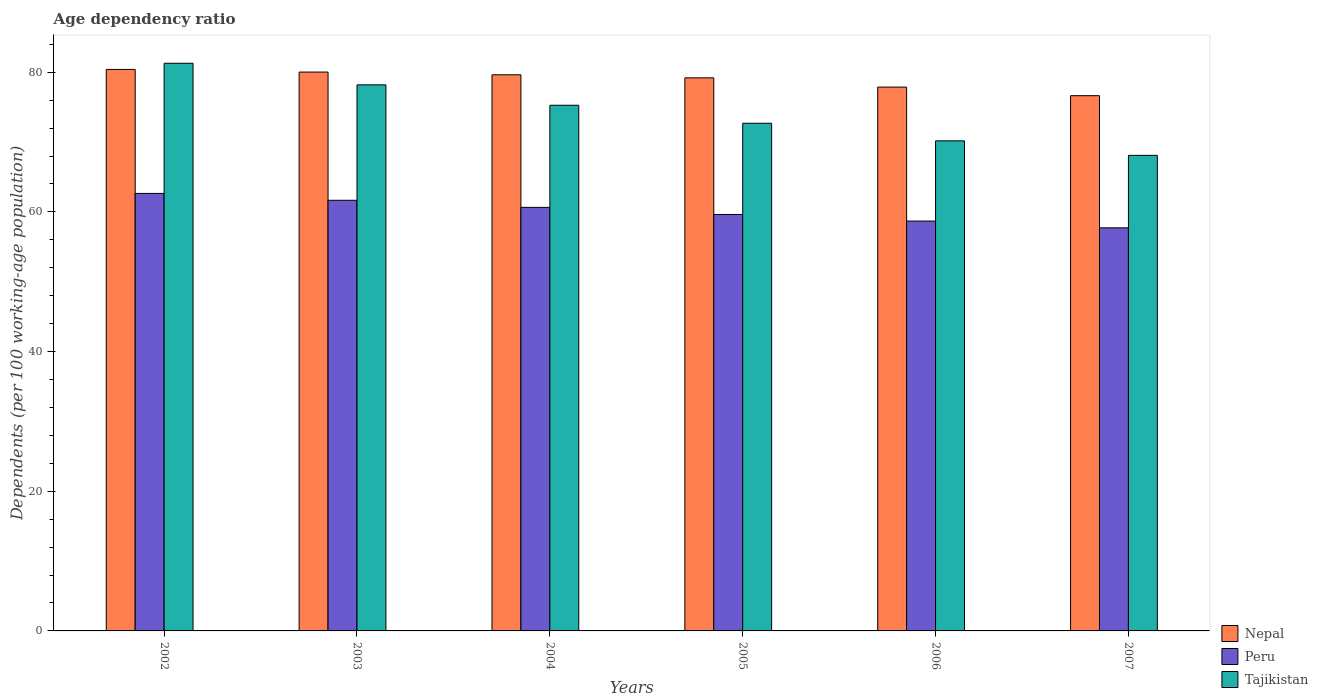How many different coloured bars are there?
Your response must be concise. 3. Are the number of bars per tick equal to the number of legend labels?
Keep it short and to the point. Yes. What is the label of the 6th group of bars from the left?
Offer a terse response. 2007. What is the age dependency ratio in in Tajikistan in 2003?
Keep it short and to the point. 78.2. Across all years, what is the maximum age dependency ratio in in Peru?
Offer a very short reply. 62.65. Across all years, what is the minimum age dependency ratio in in Nepal?
Offer a terse response. 76.65. In which year was the age dependency ratio in in Nepal minimum?
Give a very brief answer. 2007. What is the total age dependency ratio in in Tajikistan in the graph?
Give a very brief answer. 445.73. What is the difference between the age dependency ratio in in Peru in 2002 and that in 2003?
Offer a terse response. 0.98. What is the difference between the age dependency ratio in in Nepal in 2007 and the age dependency ratio in in Tajikistan in 2004?
Offer a terse response. 1.37. What is the average age dependency ratio in in Tajikistan per year?
Provide a succinct answer. 74.29. In the year 2003, what is the difference between the age dependency ratio in in Nepal and age dependency ratio in in Peru?
Keep it short and to the point. 18.36. What is the ratio of the age dependency ratio in in Peru in 2005 to that in 2006?
Make the answer very short. 1.02. Is the difference between the age dependency ratio in in Nepal in 2004 and 2007 greater than the difference between the age dependency ratio in in Peru in 2004 and 2007?
Make the answer very short. Yes. What is the difference between the highest and the second highest age dependency ratio in in Peru?
Make the answer very short. 0.98. What is the difference between the highest and the lowest age dependency ratio in in Tajikistan?
Offer a very short reply. 13.19. What does the 1st bar from the left in 2006 represents?
Ensure brevity in your answer.  Nepal. How many bars are there?
Ensure brevity in your answer.  18. How many years are there in the graph?
Your answer should be very brief. 6. What is the difference between two consecutive major ticks on the Y-axis?
Your response must be concise. 20. Are the values on the major ticks of Y-axis written in scientific E-notation?
Your answer should be very brief. No. Where does the legend appear in the graph?
Give a very brief answer. Bottom right. How many legend labels are there?
Your response must be concise. 3. What is the title of the graph?
Provide a short and direct response. Age dependency ratio. Does "Libya" appear as one of the legend labels in the graph?
Keep it short and to the point. No. What is the label or title of the Y-axis?
Make the answer very short. Dependents (per 100 working-age population). What is the Dependents (per 100 working-age population) of Nepal in 2002?
Your answer should be compact. 80.41. What is the Dependents (per 100 working-age population) of Peru in 2002?
Your answer should be very brief. 62.65. What is the Dependents (per 100 working-age population) in Tajikistan in 2002?
Make the answer very short. 81.29. What is the Dependents (per 100 working-age population) of Nepal in 2003?
Ensure brevity in your answer.  80.03. What is the Dependents (per 100 working-age population) of Peru in 2003?
Provide a succinct answer. 61.67. What is the Dependents (per 100 working-age population) of Tajikistan in 2003?
Give a very brief answer. 78.2. What is the Dependents (per 100 working-age population) in Nepal in 2004?
Keep it short and to the point. 79.64. What is the Dependents (per 100 working-age population) of Peru in 2004?
Keep it short and to the point. 60.65. What is the Dependents (per 100 working-age population) of Tajikistan in 2004?
Make the answer very short. 75.27. What is the Dependents (per 100 working-age population) of Nepal in 2005?
Ensure brevity in your answer.  79.2. What is the Dependents (per 100 working-age population) of Peru in 2005?
Make the answer very short. 59.63. What is the Dependents (per 100 working-age population) of Tajikistan in 2005?
Keep it short and to the point. 72.7. What is the Dependents (per 100 working-age population) in Nepal in 2006?
Your answer should be compact. 77.88. What is the Dependents (per 100 working-age population) in Peru in 2006?
Offer a very short reply. 58.69. What is the Dependents (per 100 working-age population) in Tajikistan in 2006?
Make the answer very short. 70.18. What is the Dependents (per 100 working-age population) in Nepal in 2007?
Keep it short and to the point. 76.65. What is the Dependents (per 100 working-age population) in Peru in 2007?
Your response must be concise. 57.72. What is the Dependents (per 100 working-age population) in Tajikistan in 2007?
Offer a very short reply. 68.1. Across all years, what is the maximum Dependents (per 100 working-age population) of Nepal?
Your answer should be compact. 80.41. Across all years, what is the maximum Dependents (per 100 working-age population) in Peru?
Offer a terse response. 62.65. Across all years, what is the maximum Dependents (per 100 working-age population) of Tajikistan?
Make the answer very short. 81.29. Across all years, what is the minimum Dependents (per 100 working-age population) of Nepal?
Your response must be concise. 76.65. Across all years, what is the minimum Dependents (per 100 working-age population) of Peru?
Provide a succinct answer. 57.72. Across all years, what is the minimum Dependents (per 100 working-age population) of Tajikistan?
Your answer should be very brief. 68.1. What is the total Dependents (per 100 working-age population) of Nepal in the graph?
Provide a succinct answer. 473.79. What is the total Dependents (per 100 working-age population) of Peru in the graph?
Your answer should be very brief. 361.02. What is the total Dependents (per 100 working-age population) in Tajikistan in the graph?
Your answer should be compact. 445.73. What is the difference between the Dependents (per 100 working-age population) of Nepal in 2002 and that in 2003?
Offer a very short reply. 0.38. What is the difference between the Dependents (per 100 working-age population) of Peru in 2002 and that in 2003?
Ensure brevity in your answer.  0.98. What is the difference between the Dependents (per 100 working-age population) in Tajikistan in 2002 and that in 2003?
Make the answer very short. 3.09. What is the difference between the Dependents (per 100 working-age population) of Nepal in 2002 and that in 2004?
Ensure brevity in your answer.  0.77. What is the difference between the Dependents (per 100 working-age population) of Peru in 2002 and that in 2004?
Your answer should be compact. 2. What is the difference between the Dependents (per 100 working-age population) of Tajikistan in 2002 and that in 2004?
Make the answer very short. 6.01. What is the difference between the Dependents (per 100 working-age population) of Nepal in 2002 and that in 2005?
Provide a short and direct response. 1.21. What is the difference between the Dependents (per 100 working-age population) of Peru in 2002 and that in 2005?
Your answer should be compact. 3.02. What is the difference between the Dependents (per 100 working-age population) in Tajikistan in 2002 and that in 2005?
Keep it short and to the point. 8.59. What is the difference between the Dependents (per 100 working-age population) of Nepal in 2002 and that in 2006?
Keep it short and to the point. 2.53. What is the difference between the Dependents (per 100 working-age population) of Peru in 2002 and that in 2006?
Provide a short and direct response. 3.96. What is the difference between the Dependents (per 100 working-age population) of Tajikistan in 2002 and that in 2006?
Offer a terse response. 11.11. What is the difference between the Dependents (per 100 working-age population) of Nepal in 2002 and that in 2007?
Provide a short and direct response. 3.76. What is the difference between the Dependents (per 100 working-age population) in Peru in 2002 and that in 2007?
Provide a short and direct response. 4.93. What is the difference between the Dependents (per 100 working-age population) of Tajikistan in 2002 and that in 2007?
Keep it short and to the point. 13.19. What is the difference between the Dependents (per 100 working-age population) of Nepal in 2003 and that in 2004?
Provide a succinct answer. 0.39. What is the difference between the Dependents (per 100 working-age population) in Peru in 2003 and that in 2004?
Keep it short and to the point. 1.01. What is the difference between the Dependents (per 100 working-age population) in Tajikistan in 2003 and that in 2004?
Offer a very short reply. 2.92. What is the difference between the Dependents (per 100 working-age population) of Nepal in 2003 and that in 2005?
Your answer should be compact. 0.83. What is the difference between the Dependents (per 100 working-age population) of Peru in 2003 and that in 2005?
Offer a very short reply. 2.03. What is the difference between the Dependents (per 100 working-age population) in Tajikistan in 2003 and that in 2005?
Provide a short and direct response. 5.5. What is the difference between the Dependents (per 100 working-age population) in Nepal in 2003 and that in 2006?
Provide a succinct answer. 2.15. What is the difference between the Dependents (per 100 working-age population) in Peru in 2003 and that in 2006?
Provide a succinct answer. 2.97. What is the difference between the Dependents (per 100 working-age population) in Tajikistan in 2003 and that in 2006?
Your response must be concise. 8.02. What is the difference between the Dependents (per 100 working-age population) of Nepal in 2003 and that in 2007?
Your response must be concise. 3.38. What is the difference between the Dependents (per 100 working-age population) in Peru in 2003 and that in 2007?
Your answer should be very brief. 3.94. What is the difference between the Dependents (per 100 working-age population) in Tajikistan in 2003 and that in 2007?
Offer a very short reply. 10.09. What is the difference between the Dependents (per 100 working-age population) in Nepal in 2004 and that in 2005?
Your response must be concise. 0.44. What is the difference between the Dependents (per 100 working-age population) in Peru in 2004 and that in 2005?
Ensure brevity in your answer.  1.02. What is the difference between the Dependents (per 100 working-age population) in Tajikistan in 2004 and that in 2005?
Your answer should be very brief. 2.58. What is the difference between the Dependents (per 100 working-age population) of Nepal in 2004 and that in 2006?
Your answer should be very brief. 1.76. What is the difference between the Dependents (per 100 working-age population) of Peru in 2004 and that in 2006?
Your response must be concise. 1.96. What is the difference between the Dependents (per 100 working-age population) in Tajikistan in 2004 and that in 2006?
Your response must be concise. 5.1. What is the difference between the Dependents (per 100 working-age population) of Nepal in 2004 and that in 2007?
Provide a succinct answer. 2.99. What is the difference between the Dependents (per 100 working-age population) in Peru in 2004 and that in 2007?
Provide a succinct answer. 2.93. What is the difference between the Dependents (per 100 working-age population) of Tajikistan in 2004 and that in 2007?
Give a very brief answer. 7.17. What is the difference between the Dependents (per 100 working-age population) of Nepal in 2005 and that in 2006?
Your answer should be very brief. 1.32. What is the difference between the Dependents (per 100 working-age population) of Peru in 2005 and that in 2006?
Keep it short and to the point. 0.94. What is the difference between the Dependents (per 100 working-age population) in Tajikistan in 2005 and that in 2006?
Your response must be concise. 2.52. What is the difference between the Dependents (per 100 working-age population) of Nepal in 2005 and that in 2007?
Your answer should be very brief. 2.55. What is the difference between the Dependents (per 100 working-age population) of Peru in 2005 and that in 2007?
Provide a short and direct response. 1.91. What is the difference between the Dependents (per 100 working-age population) in Tajikistan in 2005 and that in 2007?
Provide a short and direct response. 4.59. What is the difference between the Dependents (per 100 working-age population) of Nepal in 2006 and that in 2007?
Provide a succinct answer. 1.23. What is the difference between the Dependents (per 100 working-age population) in Peru in 2006 and that in 2007?
Your answer should be compact. 0.97. What is the difference between the Dependents (per 100 working-age population) in Tajikistan in 2006 and that in 2007?
Keep it short and to the point. 2.08. What is the difference between the Dependents (per 100 working-age population) of Nepal in 2002 and the Dependents (per 100 working-age population) of Peru in 2003?
Provide a succinct answer. 18.74. What is the difference between the Dependents (per 100 working-age population) of Nepal in 2002 and the Dependents (per 100 working-age population) of Tajikistan in 2003?
Your answer should be compact. 2.21. What is the difference between the Dependents (per 100 working-age population) of Peru in 2002 and the Dependents (per 100 working-age population) of Tajikistan in 2003?
Offer a terse response. -15.54. What is the difference between the Dependents (per 100 working-age population) in Nepal in 2002 and the Dependents (per 100 working-age population) in Peru in 2004?
Your answer should be very brief. 19.75. What is the difference between the Dependents (per 100 working-age population) in Nepal in 2002 and the Dependents (per 100 working-age population) in Tajikistan in 2004?
Provide a succinct answer. 5.13. What is the difference between the Dependents (per 100 working-age population) of Peru in 2002 and the Dependents (per 100 working-age population) of Tajikistan in 2004?
Offer a terse response. -12.62. What is the difference between the Dependents (per 100 working-age population) of Nepal in 2002 and the Dependents (per 100 working-age population) of Peru in 2005?
Provide a succinct answer. 20.77. What is the difference between the Dependents (per 100 working-age population) in Nepal in 2002 and the Dependents (per 100 working-age population) in Tajikistan in 2005?
Give a very brief answer. 7.71. What is the difference between the Dependents (per 100 working-age population) of Peru in 2002 and the Dependents (per 100 working-age population) of Tajikistan in 2005?
Make the answer very short. -10.05. What is the difference between the Dependents (per 100 working-age population) of Nepal in 2002 and the Dependents (per 100 working-age population) of Peru in 2006?
Keep it short and to the point. 21.71. What is the difference between the Dependents (per 100 working-age population) of Nepal in 2002 and the Dependents (per 100 working-age population) of Tajikistan in 2006?
Provide a short and direct response. 10.23. What is the difference between the Dependents (per 100 working-age population) in Peru in 2002 and the Dependents (per 100 working-age population) in Tajikistan in 2006?
Ensure brevity in your answer.  -7.53. What is the difference between the Dependents (per 100 working-age population) of Nepal in 2002 and the Dependents (per 100 working-age population) of Peru in 2007?
Offer a terse response. 22.68. What is the difference between the Dependents (per 100 working-age population) in Nepal in 2002 and the Dependents (per 100 working-age population) in Tajikistan in 2007?
Offer a very short reply. 12.3. What is the difference between the Dependents (per 100 working-age population) of Peru in 2002 and the Dependents (per 100 working-age population) of Tajikistan in 2007?
Give a very brief answer. -5.45. What is the difference between the Dependents (per 100 working-age population) of Nepal in 2003 and the Dependents (per 100 working-age population) of Peru in 2004?
Provide a short and direct response. 19.38. What is the difference between the Dependents (per 100 working-age population) of Nepal in 2003 and the Dependents (per 100 working-age population) of Tajikistan in 2004?
Offer a very short reply. 4.75. What is the difference between the Dependents (per 100 working-age population) in Peru in 2003 and the Dependents (per 100 working-age population) in Tajikistan in 2004?
Give a very brief answer. -13.61. What is the difference between the Dependents (per 100 working-age population) of Nepal in 2003 and the Dependents (per 100 working-age population) of Peru in 2005?
Offer a terse response. 20.39. What is the difference between the Dependents (per 100 working-age population) of Nepal in 2003 and the Dependents (per 100 working-age population) of Tajikistan in 2005?
Provide a short and direct response. 7.33. What is the difference between the Dependents (per 100 working-age population) of Peru in 2003 and the Dependents (per 100 working-age population) of Tajikistan in 2005?
Ensure brevity in your answer.  -11.03. What is the difference between the Dependents (per 100 working-age population) in Nepal in 2003 and the Dependents (per 100 working-age population) in Peru in 2006?
Provide a short and direct response. 21.33. What is the difference between the Dependents (per 100 working-age population) of Nepal in 2003 and the Dependents (per 100 working-age population) of Tajikistan in 2006?
Your response must be concise. 9.85. What is the difference between the Dependents (per 100 working-age population) of Peru in 2003 and the Dependents (per 100 working-age population) of Tajikistan in 2006?
Your answer should be compact. -8.51. What is the difference between the Dependents (per 100 working-age population) in Nepal in 2003 and the Dependents (per 100 working-age population) in Peru in 2007?
Keep it short and to the point. 22.3. What is the difference between the Dependents (per 100 working-age population) of Nepal in 2003 and the Dependents (per 100 working-age population) of Tajikistan in 2007?
Offer a very short reply. 11.92. What is the difference between the Dependents (per 100 working-age population) in Peru in 2003 and the Dependents (per 100 working-age population) in Tajikistan in 2007?
Your response must be concise. -6.44. What is the difference between the Dependents (per 100 working-age population) in Nepal in 2004 and the Dependents (per 100 working-age population) in Peru in 2005?
Your answer should be compact. 20. What is the difference between the Dependents (per 100 working-age population) in Nepal in 2004 and the Dependents (per 100 working-age population) in Tajikistan in 2005?
Offer a terse response. 6.94. What is the difference between the Dependents (per 100 working-age population) in Peru in 2004 and the Dependents (per 100 working-age population) in Tajikistan in 2005?
Make the answer very short. -12.05. What is the difference between the Dependents (per 100 working-age population) in Nepal in 2004 and the Dependents (per 100 working-age population) in Peru in 2006?
Offer a very short reply. 20.94. What is the difference between the Dependents (per 100 working-age population) in Nepal in 2004 and the Dependents (per 100 working-age population) in Tajikistan in 2006?
Offer a very short reply. 9.46. What is the difference between the Dependents (per 100 working-age population) in Peru in 2004 and the Dependents (per 100 working-age population) in Tajikistan in 2006?
Your answer should be compact. -9.53. What is the difference between the Dependents (per 100 working-age population) of Nepal in 2004 and the Dependents (per 100 working-age population) of Peru in 2007?
Offer a terse response. 21.91. What is the difference between the Dependents (per 100 working-age population) in Nepal in 2004 and the Dependents (per 100 working-age population) in Tajikistan in 2007?
Provide a short and direct response. 11.53. What is the difference between the Dependents (per 100 working-age population) of Peru in 2004 and the Dependents (per 100 working-age population) of Tajikistan in 2007?
Your answer should be very brief. -7.45. What is the difference between the Dependents (per 100 working-age population) of Nepal in 2005 and the Dependents (per 100 working-age population) of Peru in 2006?
Offer a very short reply. 20.51. What is the difference between the Dependents (per 100 working-age population) in Nepal in 2005 and the Dependents (per 100 working-age population) in Tajikistan in 2006?
Your response must be concise. 9.02. What is the difference between the Dependents (per 100 working-age population) of Peru in 2005 and the Dependents (per 100 working-age population) of Tajikistan in 2006?
Give a very brief answer. -10.54. What is the difference between the Dependents (per 100 working-age population) of Nepal in 2005 and the Dependents (per 100 working-age population) of Peru in 2007?
Give a very brief answer. 21.48. What is the difference between the Dependents (per 100 working-age population) of Nepal in 2005 and the Dependents (per 100 working-age population) of Tajikistan in 2007?
Your response must be concise. 11.1. What is the difference between the Dependents (per 100 working-age population) of Peru in 2005 and the Dependents (per 100 working-age population) of Tajikistan in 2007?
Give a very brief answer. -8.47. What is the difference between the Dependents (per 100 working-age population) in Nepal in 2006 and the Dependents (per 100 working-age population) in Peru in 2007?
Provide a short and direct response. 20.15. What is the difference between the Dependents (per 100 working-age population) of Nepal in 2006 and the Dependents (per 100 working-age population) of Tajikistan in 2007?
Keep it short and to the point. 9.77. What is the difference between the Dependents (per 100 working-age population) in Peru in 2006 and the Dependents (per 100 working-age population) in Tajikistan in 2007?
Make the answer very short. -9.41. What is the average Dependents (per 100 working-age population) in Nepal per year?
Make the answer very short. 78.96. What is the average Dependents (per 100 working-age population) of Peru per year?
Offer a terse response. 60.17. What is the average Dependents (per 100 working-age population) of Tajikistan per year?
Provide a short and direct response. 74.29. In the year 2002, what is the difference between the Dependents (per 100 working-age population) in Nepal and Dependents (per 100 working-age population) in Peru?
Offer a terse response. 17.75. In the year 2002, what is the difference between the Dependents (per 100 working-age population) in Nepal and Dependents (per 100 working-age population) in Tajikistan?
Offer a very short reply. -0.88. In the year 2002, what is the difference between the Dependents (per 100 working-age population) in Peru and Dependents (per 100 working-age population) in Tajikistan?
Offer a very short reply. -18.64. In the year 2003, what is the difference between the Dependents (per 100 working-age population) in Nepal and Dependents (per 100 working-age population) in Peru?
Offer a terse response. 18.36. In the year 2003, what is the difference between the Dependents (per 100 working-age population) of Nepal and Dependents (per 100 working-age population) of Tajikistan?
Provide a succinct answer. 1.83. In the year 2003, what is the difference between the Dependents (per 100 working-age population) in Peru and Dependents (per 100 working-age population) in Tajikistan?
Offer a very short reply. -16.53. In the year 2004, what is the difference between the Dependents (per 100 working-age population) of Nepal and Dependents (per 100 working-age population) of Peru?
Ensure brevity in your answer.  18.99. In the year 2004, what is the difference between the Dependents (per 100 working-age population) in Nepal and Dependents (per 100 working-age population) in Tajikistan?
Keep it short and to the point. 4.36. In the year 2004, what is the difference between the Dependents (per 100 working-age population) of Peru and Dependents (per 100 working-age population) of Tajikistan?
Keep it short and to the point. -14.62. In the year 2005, what is the difference between the Dependents (per 100 working-age population) in Nepal and Dependents (per 100 working-age population) in Peru?
Provide a succinct answer. 19.56. In the year 2005, what is the difference between the Dependents (per 100 working-age population) in Nepal and Dependents (per 100 working-age population) in Tajikistan?
Your answer should be compact. 6.5. In the year 2005, what is the difference between the Dependents (per 100 working-age population) in Peru and Dependents (per 100 working-age population) in Tajikistan?
Ensure brevity in your answer.  -13.06. In the year 2006, what is the difference between the Dependents (per 100 working-age population) of Nepal and Dependents (per 100 working-age population) of Peru?
Keep it short and to the point. 19.18. In the year 2006, what is the difference between the Dependents (per 100 working-age population) of Nepal and Dependents (per 100 working-age population) of Tajikistan?
Offer a very short reply. 7.7. In the year 2006, what is the difference between the Dependents (per 100 working-age population) of Peru and Dependents (per 100 working-age population) of Tajikistan?
Your answer should be compact. -11.49. In the year 2007, what is the difference between the Dependents (per 100 working-age population) in Nepal and Dependents (per 100 working-age population) in Peru?
Ensure brevity in your answer.  18.92. In the year 2007, what is the difference between the Dependents (per 100 working-age population) of Nepal and Dependents (per 100 working-age population) of Tajikistan?
Provide a succinct answer. 8.54. In the year 2007, what is the difference between the Dependents (per 100 working-age population) of Peru and Dependents (per 100 working-age population) of Tajikistan?
Provide a succinct answer. -10.38. What is the ratio of the Dependents (per 100 working-age population) of Peru in 2002 to that in 2003?
Give a very brief answer. 1.02. What is the ratio of the Dependents (per 100 working-age population) of Tajikistan in 2002 to that in 2003?
Offer a very short reply. 1.04. What is the ratio of the Dependents (per 100 working-age population) in Nepal in 2002 to that in 2004?
Your answer should be very brief. 1.01. What is the ratio of the Dependents (per 100 working-age population) in Peru in 2002 to that in 2004?
Your answer should be very brief. 1.03. What is the ratio of the Dependents (per 100 working-age population) in Tajikistan in 2002 to that in 2004?
Make the answer very short. 1.08. What is the ratio of the Dependents (per 100 working-age population) in Nepal in 2002 to that in 2005?
Give a very brief answer. 1.02. What is the ratio of the Dependents (per 100 working-age population) in Peru in 2002 to that in 2005?
Your answer should be compact. 1.05. What is the ratio of the Dependents (per 100 working-age population) of Tajikistan in 2002 to that in 2005?
Your answer should be very brief. 1.12. What is the ratio of the Dependents (per 100 working-age population) of Nepal in 2002 to that in 2006?
Your response must be concise. 1.03. What is the ratio of the Dependents (per 100 working-age population) in Peru in 2002 to that in 2006?
Give a very brief answer. 1.07. What is the ratio of the Dependents (per 100 working-age population) in Tajikistan in 2002 to that in 2006?
Provide a succinct answer. 1.16. What is the ratio of the Dependents (per 100 working-age population) in Nepal in 2002 to that in 2007?
Offer a terse response. 1.05. What is the ratio of the Dependents (per 100 working-age population) in Peru in 2002 to that in 2007?
Offer a very short reply. 1.09. What is the ratio of the Dependents (per 100 working-age population) of Tajikistan in 2002 to that in 2007?
Your response must be concise. 1.19. What is the ratio of the Dependents (per 100 working-age population) of Peru in 2003 to that in 2004?
Provide a succinct answer. 1.02. What is the ratio of the Dependents (per 100 working-age population) of Tajikistan in 2003 to that in 2004?
Ensure brevity in your answer.  1.04. What is the ratio of the Dependents (per 100 working-age population) in Nepal in 2003 to that in 2005?
Offer a very short reply. 1.01. What is the ratio of the Dependents (per 100 working-age population) in Peru in 2003 to that in 2005?
Provide a succinct answer. 1.03. What is the ratio of the Dependents (per 100 working-age population) in Tajikistan in 2003 to that in 2005?
Your answer should be compact. 1.08. What is the ratio of the Dependents (per 100 working-age population) in Nepal in 2003 to that in 2006?
Your answer should be compact. 1.03. What is the ratio of the Dependents (per 100 working-age population) of Peru in 2003 to that in 2006?
Your answer should be compact. 1.05. What is the ratio of the Dependents (per 100 working-age population) in Tajikistan in 2003 to that in 2006?
Your answer should be very brief. 1.11. What is the ratio of the Dependents (per 100 working-age population) of Nepal in 2003 to that in 2007?
Your response must be concise. 1.04. What is the ratio of the Dependents (per 100 working-age population) in Peru in 2003 to that in 2007?
Your answer should be compact. 1.07. What is the ratio of the Dependents (per 100 working-age population) of Tajikistan in 2003 to that in 2007?
Your response must be concise. 1.15. What is the ratio of the Dependents (per 100 working-age population) of Peru in 2004 to that in 2005?
Offer a very short reply. 1.02. What is the ratio of the Dependents (per 100 working-age population) in Tajikistan in 2004 to that in 2005?
Make the answer very short. 1.04. What is the ratio of the Dependents (per 100 working-age population) of Nepal in 2004 to that in 2006?
Provide a short and direct response. 1.02. What is the ratio of the Dependents (per 100 working-age population) in Peru in 2004 to that in 2006?
Your answer should be compact. 1.03. What is the ratio of the Dependents (per 100 working-age population) in Tajikistan in 2004 to that in 2006?
Provide a succinct answer. 1.07. What is the ratio of the Dependents (per 100 working-age population) of Nepal in 2004 to that in 2007?
Offer a terse response. 1.04. What is the ratio of the Dependents (per 100 working-age population) in Peru in 2004 to that in 2007?
Give a very brief answer. 1.05. What is the ratio of the Dependents (per 100 working-age population) in Tajikistan in 2004 to that in 2007?
Keep it short and to the point. 1.11. What is the ratio of the Dependents (per 100 working-age population) in Nepal in 2005 to that in 2006?
Ensure brevity in your answer.  1.02. What is the ratio of the Dependents (per 100 working-age population) in Peru in 2005 to that in 2006?
Your answer should be very brief. 1.02. What is the ratio of the Dependents (per 100 working-age population) of Tajikistan in 2005 to that in 2006?
Provide a short and direct response. 1.04. What is the ratio of the Dependents (per 100 working-age population) in Peru in 2005 to that in 2007?
Provide a short and direct response. 1.03. What is the ratio of the Dependents (per 100 working-age population) in Tajikistan in 2005 to that in 2007?
Give a very brief answer. 1.07. What is the ratio of the Dependents (per 100 working-age population) in Nepal in 2006 to that in 2007?
Offer a very short reply. 1.02. What is the ratio of the Dependents (per 100 working-age population) of Peru in 2006 to that in 2007?
Your answer should be compact. 1.02. What is the ratio of the Dependents (per 100 working-age population) in Tajikistan in 2006 to that in 2007?
Your answer should be compact. 1.03. What is the difference between the highest and the second highest Dependents (per 100 working-age population) in Nepal?
Keep it short and to the point. 0.38. What is the difference between the highest and the second highest Dependents (per 100 working-age population) of Peru?
Offer a very short reply. 0.98. What is the difference between the highest and the second highest Dependents (per 100 working-age population) in Tajikistan?
Ensure brevity in your answer.  3.09. What is the difference between the highest and the lowest Dependents (per 100 working-age population) of Nepal?
Your response must be concise. 3.76. What is the difference between the highest and the lowest Dependents (per 100 working-age population) of Peru?
Give a very brief answer. 4.93. What is the difference between the highest and the lowest Dependents (per 100 working-age population) of Tajikistan?
Your response must be concise. 13.19. 